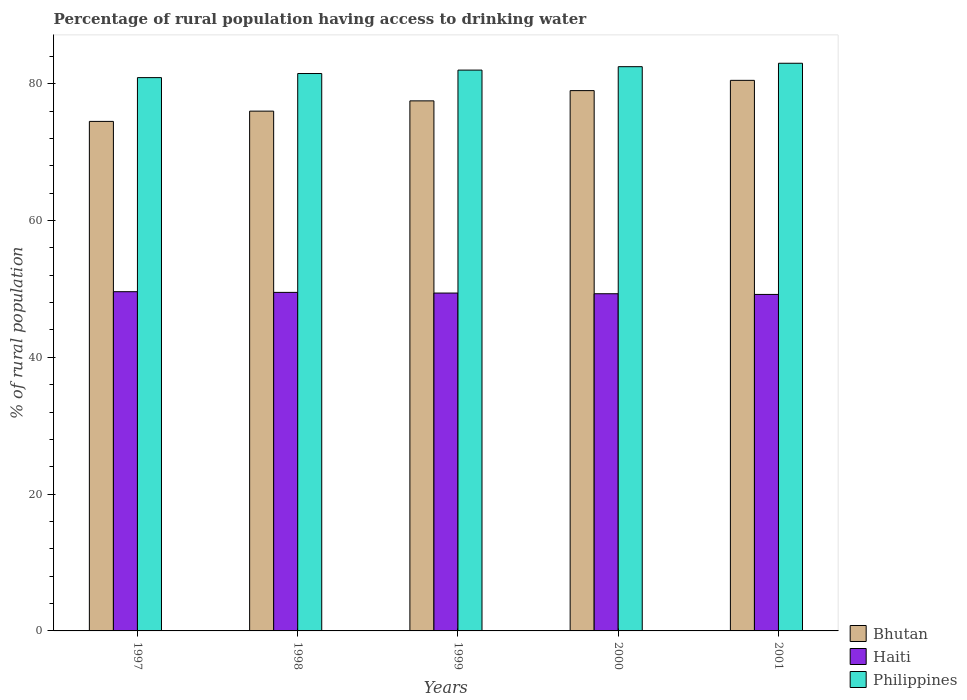How many different coloured bars are there?
Provide a succinct answer. 3. How many bars are there on the 5th tick from the left?
Your answer should be very brief. 3. How many bars are there on the 3rd tick from the right?
Give a very brief answer. 3. What is the label of the 5th group of bars from the left?
Ensure brevity in your answer.  2001. What is the percentage of rural population having access to drinking water in Haiti in 1998?
Give a very brief answer. 49.5. Across all years, what is the maximum percentage of rural population having access to drinking water in Bhutan?
Make the answer very short. 80.5. Across all years, what is the minimum percentage of rural population having access to drinking water in Haiti?
Keep it short and to the point. 49.2. What is the total percentage of rural population having access to drinking water in Haiti in the graph?
Provide a short and direct response. 247. What is the difference between the percentage of rural population having access to drinking water in Haiti in 2000 and the percentage of rural population having access to drinking water in Bhutan in 1998?
Keep it short and to the point. -26.7. What is the average percentage of rural population having access to drinking water in Haiti per year?
Offer a terse response. 49.4. In the year 2001, what is the difference between the percentage of rural population having access to drinking water in Bhutan and percentage of rural population having access to drinking water in Philippines?
Provide a succinct answer. -2.5. What is the ratio of the percentage of rural population having access to drinking water in Haiti in 1997 to that in 1998?
Offer a very short reply. 1. Is the percentage of rural population having access to drinking water in Haiti in 1998 less than that in 2001?
Make the answer very short. No. Is the difference between the percentage of rural population having access to drinking water in Bhutan in 1999 and 2001 greater than the difference between the percentage of rural population having access to drinking water in Philippines in 1999 and 2001?
Your response must be concise. No. What is the difference between the highest and the second highest percentage of rural population having access to drinking water in Philippines?
Keep it short and to the point. 0.5. What is the difference between the highest and the lowest percentage of rural population having access to drinking water in Haiti?
Your response must be concise. 0.4. What does the 1st bar from the left in 2000 represents?
Provide a short and direct response. Bhutan. What does the 3rd bar from the right in 2001 represents?
Offer a very short reply. Bhutan. Is it the case that in every year, the sum of the percentage of rural population having access to drinking water in Philippines and percentage of rural population having access to drinking water in Bhutan is greater than the percentage of rural population having access to drinking water in Haiti?
Give a very brief answer. Yes. How many bars are there?
Provide a succinct answer. 15. How many years are there in the graph?
Give a very brief answer. 5. Are the values on the major ticks of Y-axis written in scientific E-notation?
Ensure brevity in your answer.  No. Does the graph contain any zero values?
Provide a succinct answer. No. Does the graph contain grids?
Give a very brief answer. No. How many legend labels are there?
Keep it short and to the point. 3. How are the legend labels stacked?
Give a very brief answer. Vertical. What is the title of the graph?
Provide a short and direct response. Percentage of rural population having access to drinking water. Does "Saudi Arabia" appear as one of the legend labels in the graph?
Offer a very short reply. No. What is the label or title of the X-axis?
Give a very brief answer. Years. What is the label or title of the Y-axis?
Your response must be concise. % of rural population. What is the % of rural population of Bhutan in 1997?
Keep it short and to the point. 74.5. What is the % of rural population of Haiti in 1997?
Give a very brief answer. 49.6. What is the % of rural population of Philippines in 1997?
Provide a short and direct response. 80.9. What is the % of rural population in Haiti in 1998?
Your answer should be compact. 49.5. What is the % of rural population of Philippines in 1998?
Ensure brevity in your answer.  81.5. What is the % of rural population of Bhutan in 1999?
Provide a succinct answer. 77.5. What is the % of rural population in Haiti in 1999?
Offer a very short reply. 49.4. What is the % of rural population of Philippines in 1999?
Ensure brevity in your answer.  82. What is the % of rural population of Bhutan in 2000?
Offer a very short reply. 79. What is the % of rural population in Haiti in 2000?
Your response must be concise. 49.3. What is the % of rural population of Philippines in 2000?
Make the answer very short. 82.5. What is the % of rural population of Bhutan in 2001?
Give a very brief answer. 80.5. What is the % of rural population of Haiti in 2001?
Your response must be concise. 49.2. Across all years, what is the maximum % of rural population in Bhutan?
Your response must be concise. 80.5. Across all years, what is the maximum % of rural population in Haiti?
Provide a short and direct response. 49.6. Across all years, what is the maximum % of rural population of Philippines?
Keep it short and to the point. 83. Across all years, what is the minimum % of rural population in Bhutan?
Keep it short and to the point. 74.5. Across all years, what is the minimum % of rural population in Haiti?
Keep it short and to the point. 49.2. Across all years, what is the minimum % of rural population in Philippines?
Make the answer very short. 80.9. What is the total % of rural population of Bhutan in the graph?
Keep it short and to the point. 387.5. What is the total % of rural population in Haiti in the graph?
Your answer should be very brief. 247. What is the total % of rural population in Philippines in the graph?
Give a very brief answer. 409.9. What is the difference between the % of rural population in Philippines in 1997 and that in 1998?
Offer a very short reply. -0.6. What is the difference between the % of rural population in Bhutan in 1997 and that in 1999?
Provide a short and direct response. -3. What is the difference between the % of rural population in Bhutan in 1997 and that in 2000?
Ensure brevity in your answer.  -4.5. What is the difference between the % of rural population in Bhutan in 1997 and that in 2001?
Offer a very short reply. -6. What is the difference between the % of rural population in Philippines in 1997 and that in 2001?
Make the answer very short. -2.1. What is the difference between the % of rural population of Bhutan in 1998 and that in 1999?
Your response must be concise. -1.5. What is the difference between the % of rural population of Haiti in 1998 and that in 2000?
Your response must be concise. 0.2. What is the difference between the % of rural population in Haiti in 1998 and that in 2001?
Give a very brief answer. 0.3. What is the difference between the % of rural population of Philippines in 1999 and that in 2000?
Make the answer very short. -0.5. What is the difference between the % of rural population in Haiti in 1999 and that in 2001?
Give a very brief answer. 0.2. What is the difference between the % of rural population of Philippines in 1999 and that in 2001?
Provide a short and direct response. -1. What is the difference between the % of rural population of Bhutan in 2000 and that in 2001?
Provide a short and direct response. -1.5. What is the difference between the % of rural population in Philippines in 2000 and that in 2001?
Provide a succinct answer. -0.5. What is the difference between the % of rural population of Bhutan in 1997 and the % of rural population of Philippines in 1998?
Provide a succinct answer. -7. What is the difference between the % of rural population of Haiti in 1997 and the % of rural population of Philippines in 1998?
Offer a terse response. -31.9. What is the difference between the % of rural population in Bhutan in 1997 and the % of rural population in Haiti in 1999?
Provide a short and direct response. 25.1. What is the difference between the % of rural population in Haiti in 1997 and the % of rural population in Philippines in 1999?
Keep it short and to the point. -32.4. What is the difference between the % of rural population in Bhutan in 1997 and the % of rural population in Haiti in 2000?
Your answer should be very brief. 25.2. What is the difference between the % of rural population of Haiti in 1997 and the % of rural population of Philippines in 2000?
Provide a short and direct response. -32.9. What is the difference between the % of rural population of Bhutan in 1997 and the % of rural population of Haiti in 2001?
Your answer should be compact. 25.3. What is the difference between the % of rural population of Bhutan in 1997 and the % of rural population of Philippines in 2001?
Provide a short and direct response. -8.5. What is the difference between the % of rural population of Haiti in 1997 and the % of rural population of Philippines in 2001?
Your response must be concise. -33.4. What is the difference between the % of rural population of Bhutan in 1998 and the % of rural population of Haiti in 1999?
Make the answer very short. 26.6. What is the difference between the % of rural population of Bhutan in 1998 and the % of rural population of Philippines in 1999?
Your answer should be very brief. -6. What is the difference between the % of rural population of Haiti in 1998 and the % of rural population of Philippines in 1999?
Offer a very short reply. -32.5. What is the difference between the % of rural population of Bhutan in 1998 and the % of rural population of Haiti in 2000?
Give a very brief answer. 26.7. What is the difference between the % of rural population of Bhutan in 1998 and the % of rural population of Philippines in 2000?
Offer a very short reply. -6.5. What is the difference between the % of rural population in Haiti in 1998 and the % of rural population in Philippines in 2000?
Offer a very short reply. -33. What is the difference between the % of rural population in Bhutan in 1998 and the % of rural population in Haiti in 2001?
Make the answer very short. 26.8. What is the difference between the % of rural population in Bhutan in 1998 and the % of rural population in Philippines in 2001?
Your response must be concise. -7. What is the difference between the % of rural population in Haiti in 1998 and the % of rural population in Philippines in 2001?
Your response must be concise. -33.5. What is the difference between the % of rural population of Bhutan in 1999 and the % of rural population of Haiti in 2000?
Make the answer very short. 28.2. What is the difference between the % of rural population in Bhutan in 1999 and the % of rural population in Philippines in 2000?
Give a very brief answer. -5. What is the difference between the % of rural population in Haiti in 1999 and the % of rural population in Philippines in 2000?
Offer a terse response. -33.1. What is the difference between the % of rural population of Bhutan in 1999 and the % of rural population of Haiti in 2001?
Ensure brevity in your answer.  28.3. What is the difference between the % of rural population in Haiti in 1999 and the % of rural population in Philippines in 2001?
Offer a terse response. -33.6. What is the difference between the % of rural population in Bhutan in 2000 and the % of rural population in Haiti in 2001?
Provide a succinct answer. 29.8. What is the difference between the % of rural population of Bhutan in 2000 and the % of rural population of Philippines in 2001?
Provide a short and direct response. -4. What is the difference between the % of rural population of Haiti in 2000 and the % of rural population of Philippines in 2001?
Provide a succinct answer. -33.7. What is the average % of rural population of Bhutan per year?
Your answer should be very brief. 77.5. What is the average % of rural population in Haiti per year?
Offer a very short reply. 49.4. What is the average % of rural population in Philippines per year?
Your answer should be very brief. 81.98. In the year 1997, what is the difference between the % of rural population of Bhutan and % of rural population of Haiti?
Ensure brevity in your answer.  24.9. In the year 1997, what is the difference between the % of rural population in Haiti and % of rural population in Philippines?
Make the answer very short. -31.3. In the year 1998, what is the difference between the % of rural population of Haiti and % of rural population of Philippines?
Offer a terse response. -32. In the year 1999, what is the difference between the % of rural population of Bhutan and % of rural population of Haiti?
Your response must be concise. 28.1. In the year 1999, what is the difference between the % of rural population of Bhutan and % of rural population of Philippines?
Offer a very short reply. -4.5. In the year 1999, what is the difference between the % of rural population in Haiti and % of rural population in Philippines?
Make the answer very short. -32.6. In the year 2000, what is the difference between the % of rural population in Bhutan and % of rural population in Haiti?
Make the answer very short. 29.7. In the year 2000, what is the difference between the % of rural population of Bhutan and % of rural population of Philippines?
Make the answer very short. -3.5. In the year 2000, what is the difference between the % of rural population in Haiti and % of rural population in Philippines?
Keep it short and to the point. -33.2. In the year 2001, what is the difference between the % of rural population of Bhutan and % of rural population of Haiti?
Provide a succinct answer. 31.3. In the year 2001, what is the difference between the % of rural population of Haiti and % of rural population of Philippines?
Make the answer very short. -33.8. What is the ratio of the % of rural population of Bhutan in 1997 to that in 1998?
Provide a succinct answer. 0.98. What is the ratio of the % of rural population of Haiti in 1997 to that in 1998?
Give a very brief answer. 1. What is the ratio of the % of rural population in Bhutan in 1997 to that in 1999?
Your answer should be very brief. 0.96. What is the ratio of the % of rural population of Philippines in 1997 to that in 1999?
Ensure brevity in your answer.  0.99. What is the ratio of the % of rural population in Bhutan in 1997 to that in 2000?
Your answer should be compact. 0.94. What is the ratio of the % of rural population in Haiti in 1997 to that in 2000?
Your answer should be very brief. 1.01. What is the ratio of the % of rural population in Philippines in 1997 to that in 2000?
Offer a terse response. 0.98. What is the ratio of the % of rural population in Bhutan in 1997 to that in 2001?
Make the answer very short. 0.93. What is the ratio of the % of rural population of Haiti in 1997 to that in 2001?
Keep it short and to the point. 1.01. What is the ratio of the % of rural population in Philippines in 1997 to that in 2001?
Provide a succinct answer. 0.97. What is the ratio of the % of rural population in Bhutan in 1998 to that in 1999?
Give a very brief answer. 0.98. What is the ratio of the % of rural population of Haiti in 1998 to that in 2000?
Provide a short and direct response. 1. What is the ratio of the % of rural population of Philippines in 1998 to that in 2000?
Your answer should be very brief. 0.99. What is the ratio of the % of rural population in Bhutan in 1998 to that in 2001?
Keep it short and to the point. 0.94. What is the ratio of the % of rural population of Philippines in 1998 to that in 2001?
Provide a succinct answer. 0.98. What is the ratio of the % of rural population of Haiti in 1999 to that in 2000?
Your answer should be compact. 1. What is the ratio of the % of rural population in Bhutan in 1999 to that in 2001?
Offer a very short reply. 0.96. What is the ratio of the % of rural population of Haiti in 1999 to that in 2001?
Offer a very short reply. 1. What is the ratio of the % of rural population in Bhutan in 2000 to that in 2001?
Make the answer very short. 0.98. What is the ratio of the % of rural population of Haiti in 2000 to that in 2001?
Offer a terse response. 1. What is the ratio of the % of rural population in Philippines in 2000 to that in 2001?
Your response must be concise. 0.99. What is the difference between the highest and the second highest % of rural population in Haiti?
Give a very brief answer. 0.1. What is the difference between the highest and the lowest % of rural population in Bhutan?
Keep it short and to the point. 6. What is the difference between the highest and the lowest % of rural population in Haiti?
Provide a succinct answer. 0.4. 